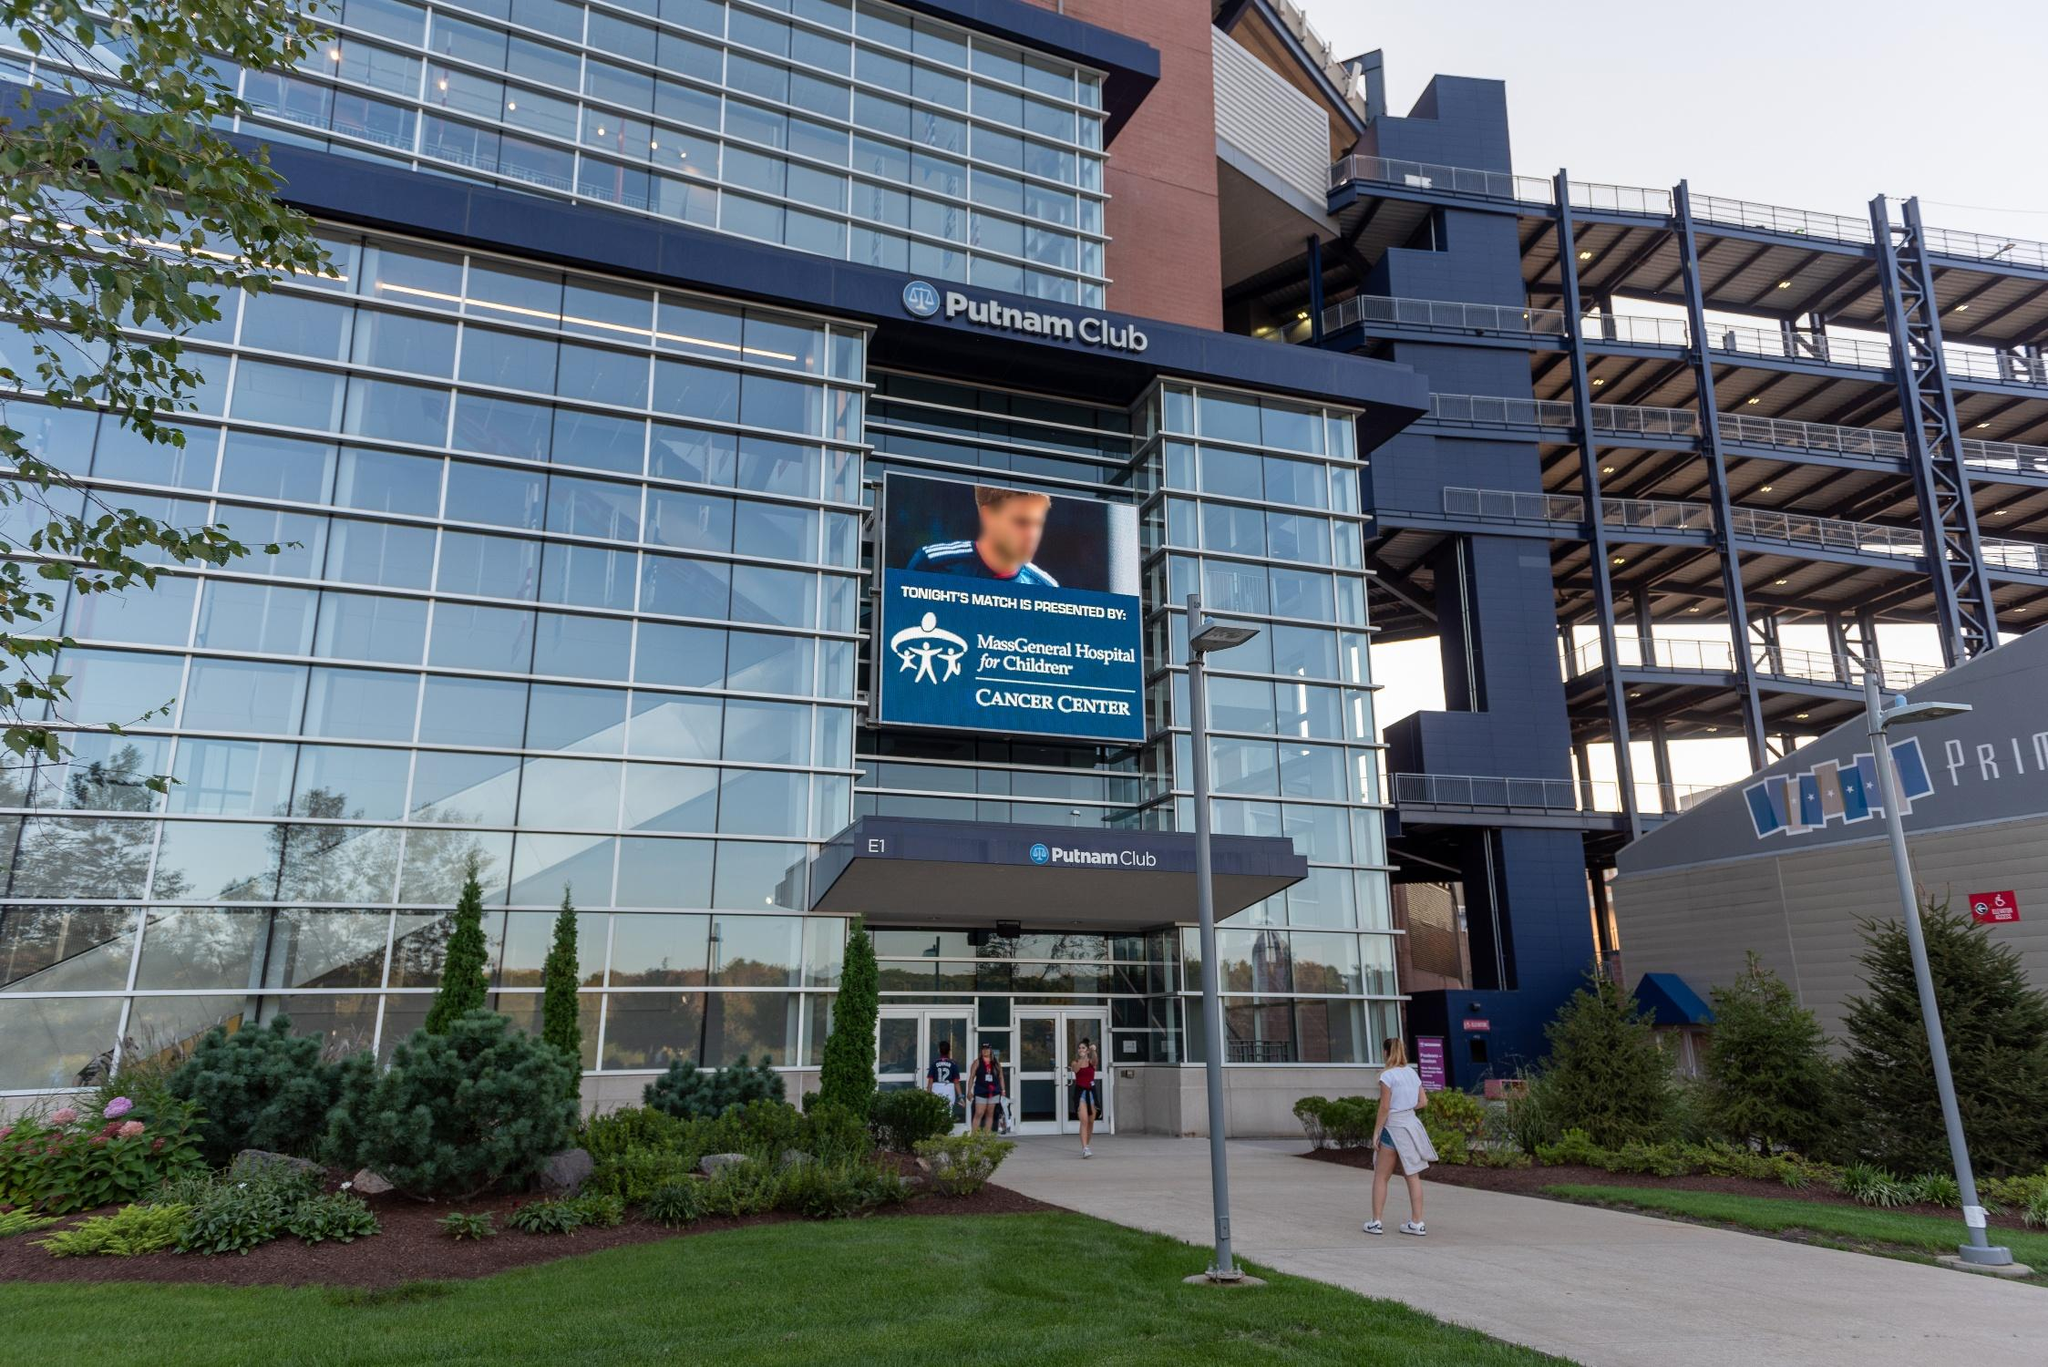Imagine a magical scenario where the Putnam Club is transformed into a fantastical realm. Describe it. In a magical twist, the Putnam Club transforms into an enchanted fortress. The glass facade morphs into shimmering crystal walls, reflecting a kaleidoscope of colors as the sun moves. The steel frame becomes intricate wrought-iron vines, twisting and curling around the structure, embedded with glowing gemstones. The landscaped area flourishes into a mystical garden with exotic flora and fauna—trees that whisper ancient secrets and flowers that emit a soft, ethereal light. Inside, grand halls are lit by floating lanterns, and the atmosphere is filled with the soft hum of enchanting music. Event attendees find themselves in a land of wonder, greeted by mythical creatures like friendly dragons and wise centaurs. Every room offers a new adventure; one might be a library of living books, while another is a banquet hall serving magical feasts that never end. The large screen outside displays not advertisements, but visions of far-off mystical lands, drawing more visitors to this newfound realm of fantasy and wonder. 